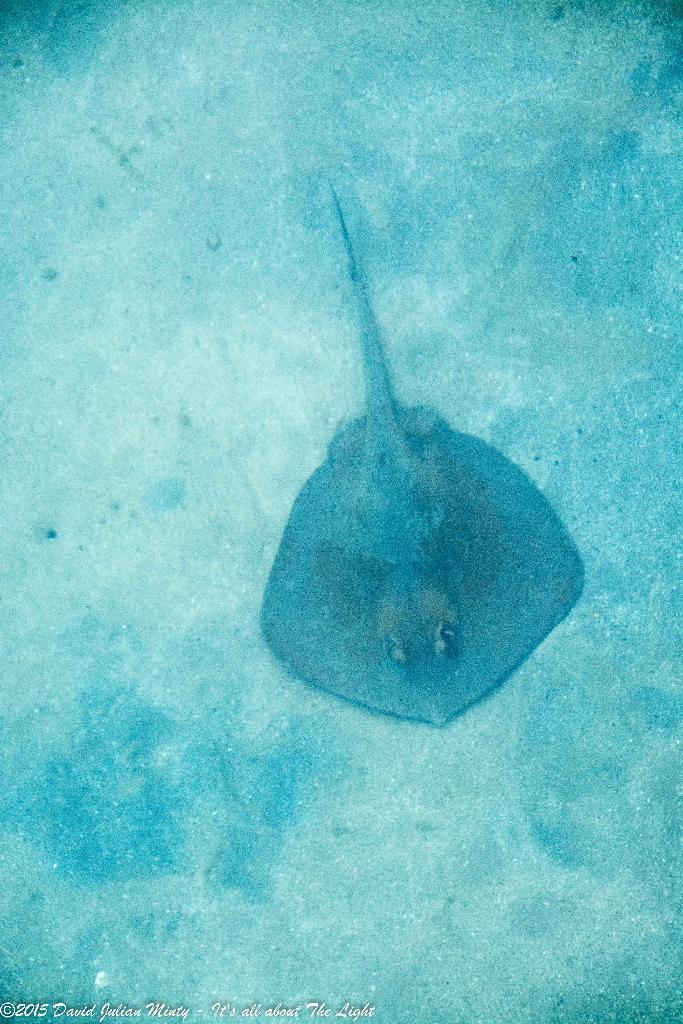How would you summarize this image in a sentence or two? Here in this picture we can see a whip-ray present on the ground underwater. 